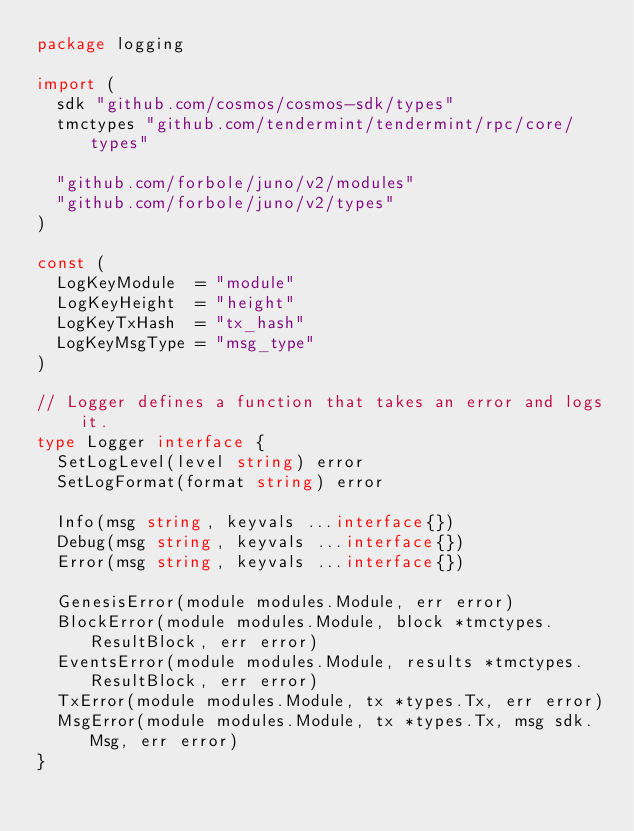<code> <loc_0><loc_0><loc_500><loc_500><_Go_>package logging

import (
	sdk "github.com/cosmos/cosmos-sdk/types"
	tmctypes "github.com/tendermint/tendermint/rpc/core/types"

	"github.com/forbole/juno/v2/modules"
	"github.com/forbole/juno/v2/types"
)

const (
	LogKeyModule  = "module"
	LogKeyHeight  = "height"
	LogKeyTxHash  = "tx_hash"
	LogKeyMsgType = "msg_type"
)

// Logger defines a function that takes an error and logs it.
type Logger interface {
	SetLogLevel(level string) error
	SetLogFormat(format string) error

	Info(msg string, keyvals ...interface{})
	Debug(msg string, keyvals ...interface{})
	Error(msg string, keyvals ...interface{})

	GenesisError(module modules.Module, err error)
	BlockError(module modules.Module, block *tmctypes.ResultBlock, err error)
	EventsError(module modules.Module, results *tmctypes.ResultBlock, err error)
	TxError(module modules.Module, tx *types.Tx, err error)
	MsgError(module modules.Module, tx *types.Tx, msg sdk.Msg, err error)
}
</code> 